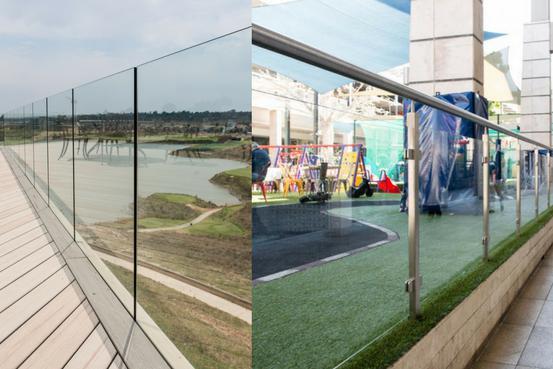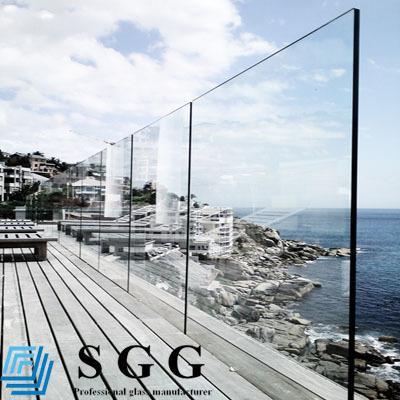The first image is the image on the left, the second image is the image on the right. Considering the images on both sides, is "Each image features a glass-paneled balcony alongside a deck with plank boards, overlooking similar scenery." valid? Answer yes or no. Yes. The first image is the image on the left, the second image is the image on the right. Assess this claim about the two images: "Both images are outside.". Correct or not? Answer yes or no. Yes. 